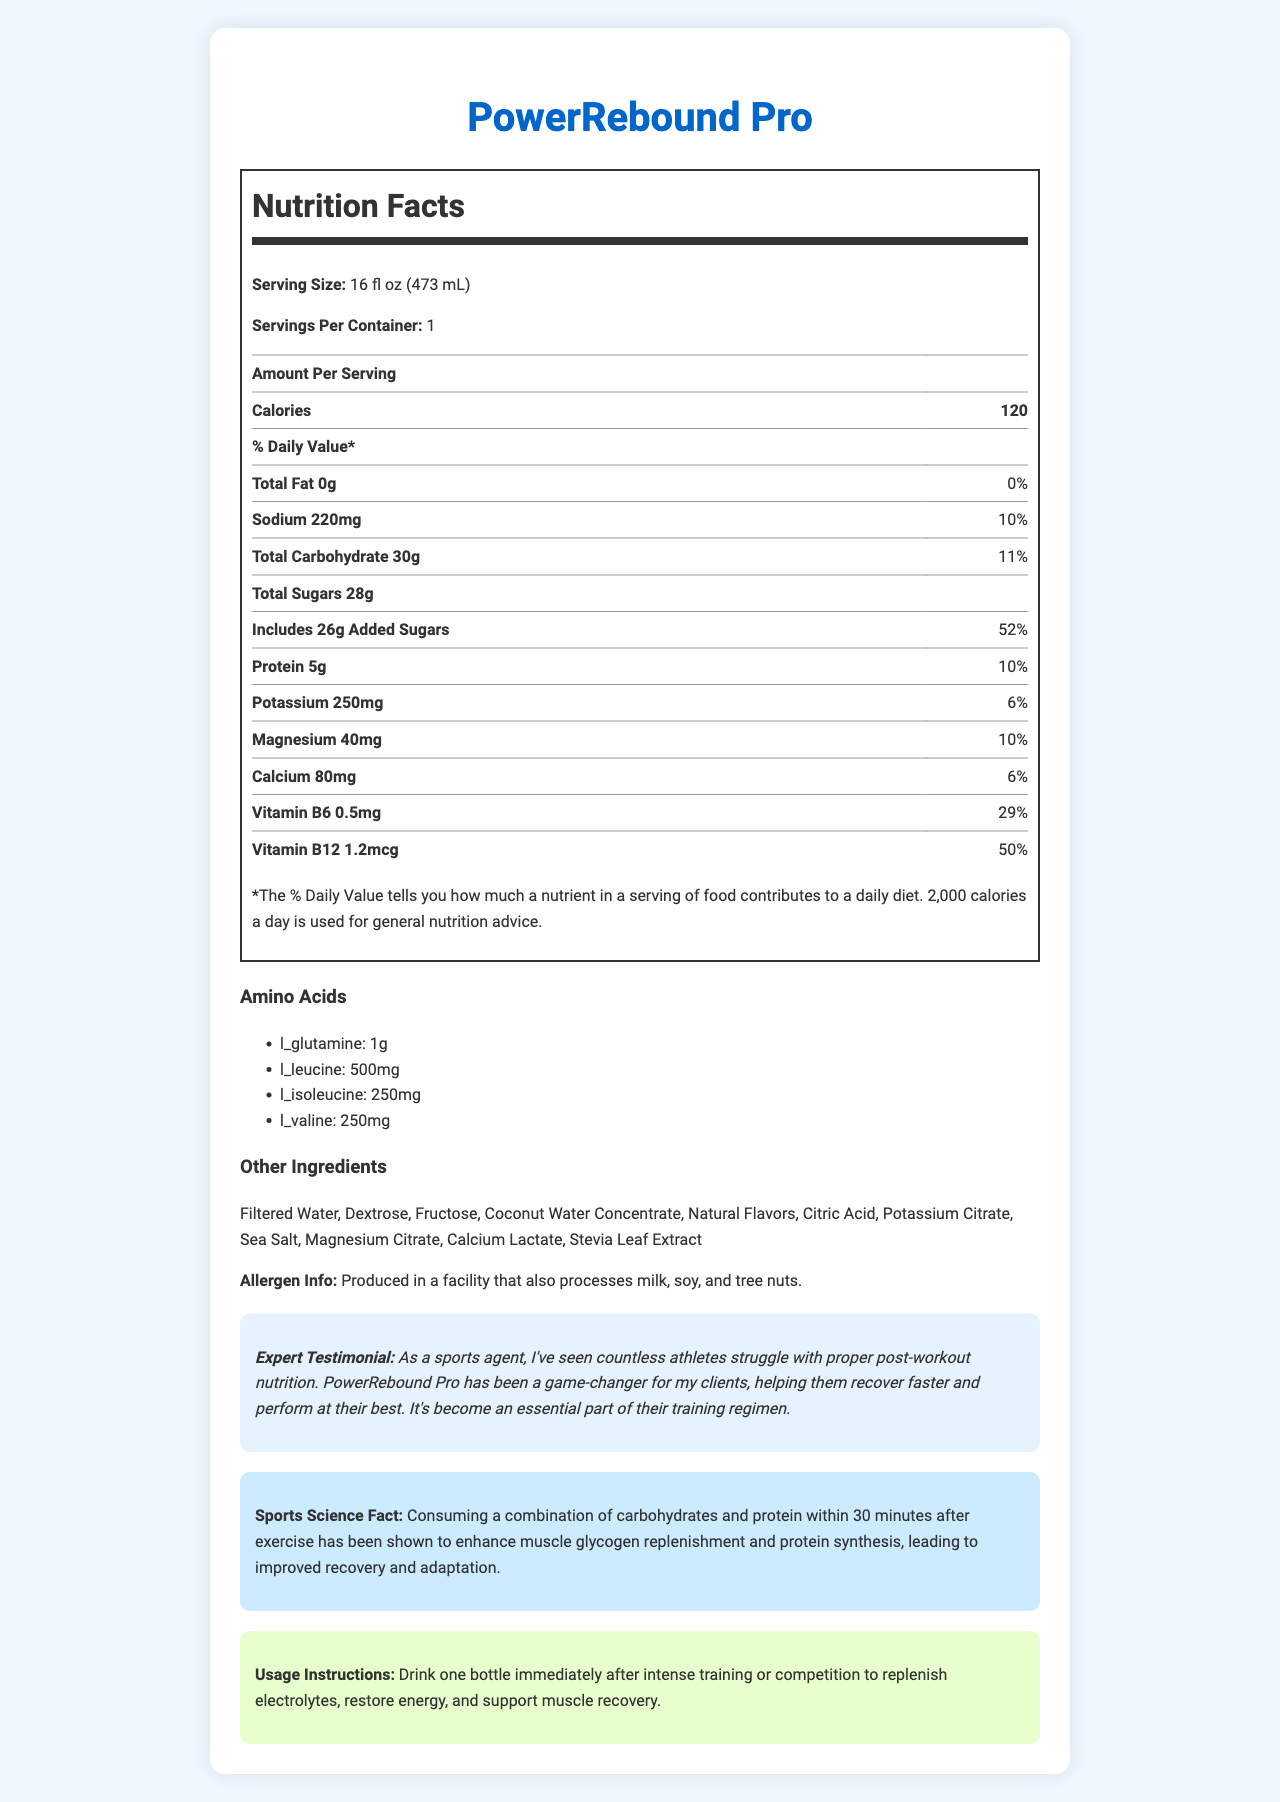What is the serving size for PowerRebound Pro? The serving size is clearly stated in the nutrition facts label as 16 fl oz (473 mL).
Answer: 16 fl oz (473 mL) How many calories does one serving of PowerRebound Pro contain? According to the nutrition facts, one serving contains 120 calories.
Answer: 120 List the amino acids present in PowerRebound Pro and their amounts. The amounts of each amino acid are listed under the "Amino Acids" section.
Answer: L-Glutamine: 1g, L-Leucine: 500mg, L-Isoleucine: 250mg, L-Valine: 250mg What is the percentage daily value of added sugars in one serving? The nutrition facts indicate that added sugars make up 52% of the daily value.
Answer: 52% What is the combined amount of sodium and potassium in one serving of PowerRebound Pro? Sodium is 220mg and potassium is 250mg. Adding these together gives 470mg.
Answer: 470mg How much protein is in one serving of PowerRebound Pro? The nutrition facts state that one serving contains 5g of protein.
Answer: 5g Which ingredient provides sweetness to the drink? A. Filtered Water B. Stevia Leaf Extract C. Coconut Water Concentrate D. Citric Acid Stevia Leaf Extract is known for its sweetness and is listed among the ingredients.
Answer: B. Stevia Leaf Extract How much vitamin B12 is in one serving, and what percentage of the daily value does it represent? A. 0.5mg, 29% B. 1.2mcg, 50% C. 80mg, 6% Vitamin B12 is listed as 1.2mcg, which corresponds to 50% of the daily value.
Answer: B. 1.2mcg, 50% Does PowerRebound Pro contain any fat? The nutrition facts label shows 0g of total fat.
Answer: No Is the product produced in a facility that processes allergens? The allergen information states that it is produced in a facility that processes milk, soy, and tree nuts.
Answer: Yes Summarize the main nutritional benefits of PowerRebound Pro. The document details the product's contents, focusing on its role in post-workout recovery by providing essential nutrients and electrolytes.
Answer: PowerRebound Pro is a post-workout recovery drink that provides a combination of moderate calories, essential electrolytes, amino acids for muscle recovery, and vitamins. It is low in fat, has significant added sugars, and supports quick recovery through a mix of carbohydrates and proteins. How much magnesium does one serving contain? The nutrition facts indicate that one serving contains 40mg of magnesium.
Answer: 40mg What is the primary purpose of drinking PowerRebound Pro according to the usage instructions? The usage instructions specify that the drink should be consumed immediately after intense training or competition for these benefits.
Answer: To replenish electrolytes, restore energy, and support muscle recovery after intense training or competition. Are there any artificial ingredients listed in PowerRebound Pro? All ingredients listed are natural, such as filtered water, dextrose, fructose, and others without any artificial additives.
Answer: No What is the significance of consuming carbohydrates and protein after exercise according to the sports science fact? The sports science fact explains the benefits of consuming a mix of carbohydrates and proteins after exercise.
Answer: Enhances muscle glycogen replenishment and protein synthesis, leading to improved recovery and adaptation. What is the caffeine content of PowerRebound Pro? The document does not provide any details about the caffeine content.
Answer: Not enough information 